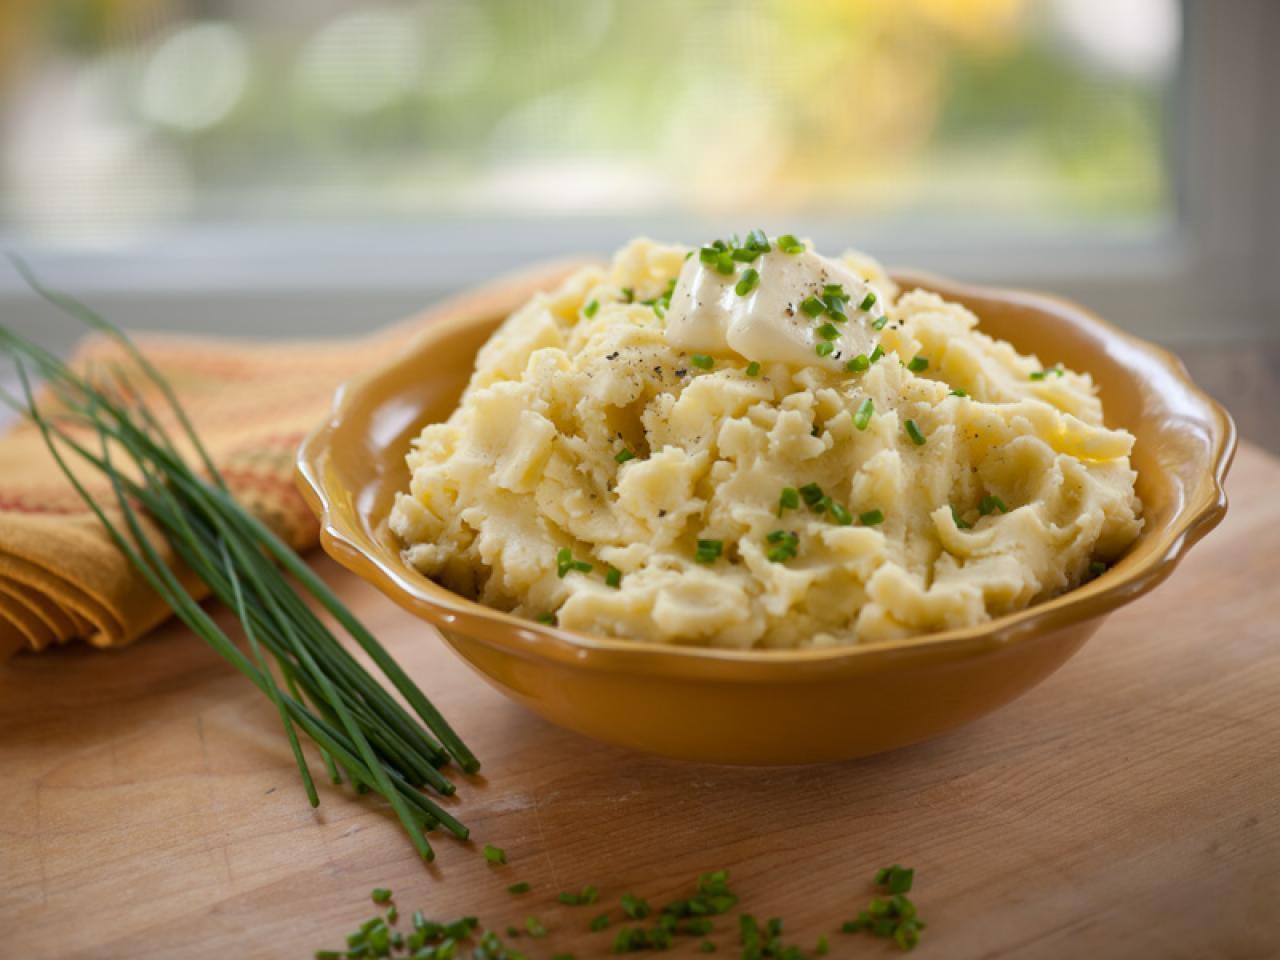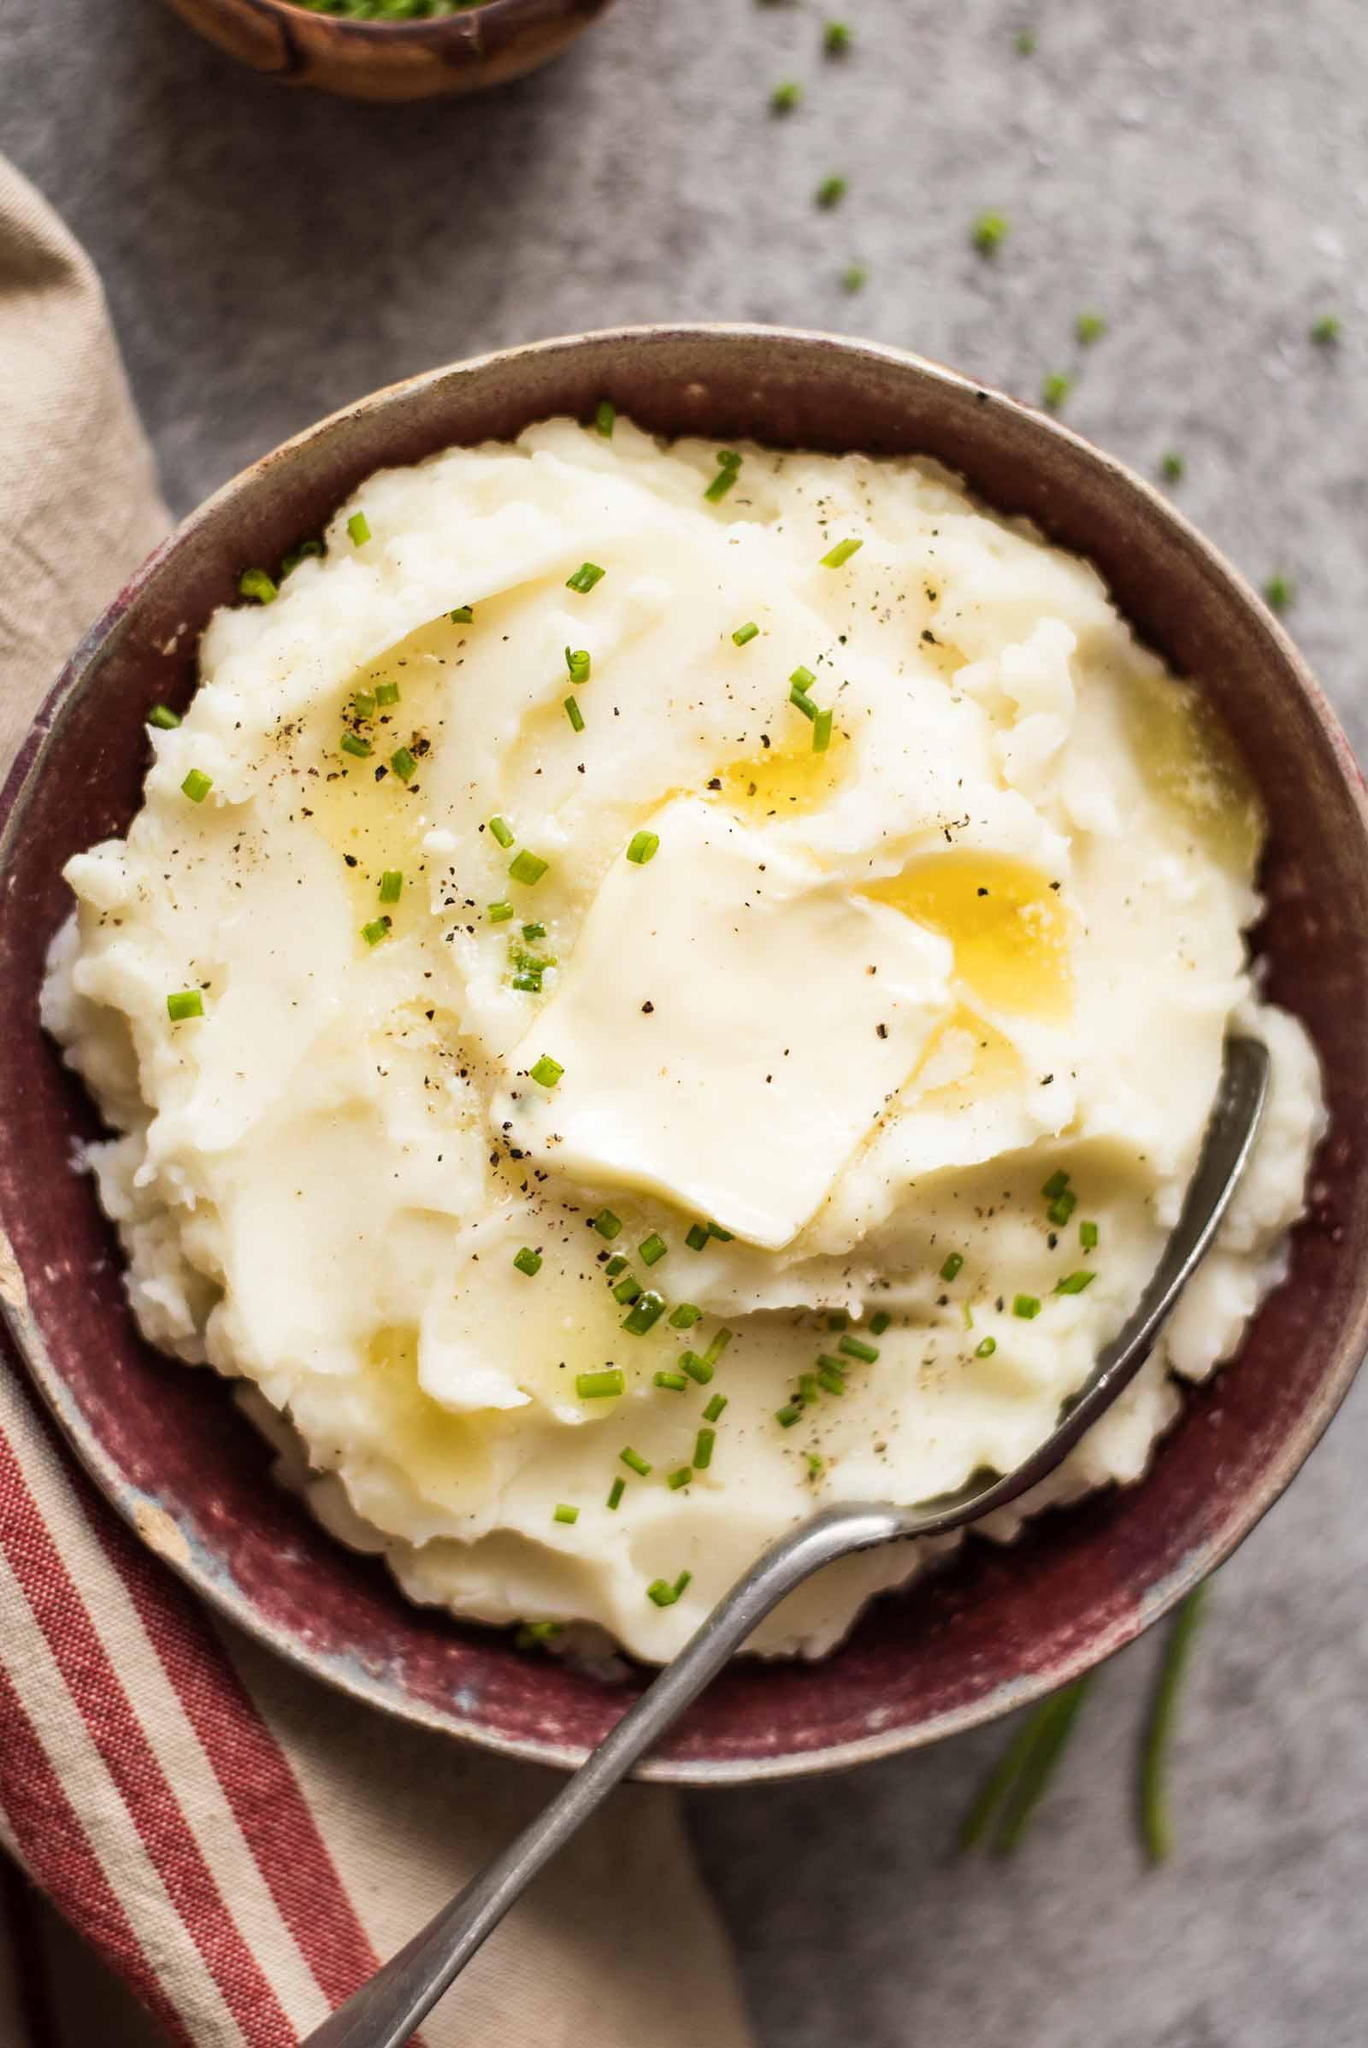The first image is the image on the left, the second image is the image on the right. Examine the images to the left and right. Is the description "Left image shows mashed potatoes in a round bowl with fluted edges." accurate? Answer yes or no. Yes. 